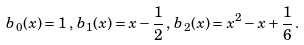<formula> <loc_0><loc_0><loc_500><loc_500>b _ { 0 } ( x ) = 1 \, , \, b _ { 1 } ( x ) = x - \frac { 1 } { 2 } \, , \, b _ { 2 } ( x ) = x ^ { 2 } - x + \frac { 1 } { 6 } \, .</formula> 